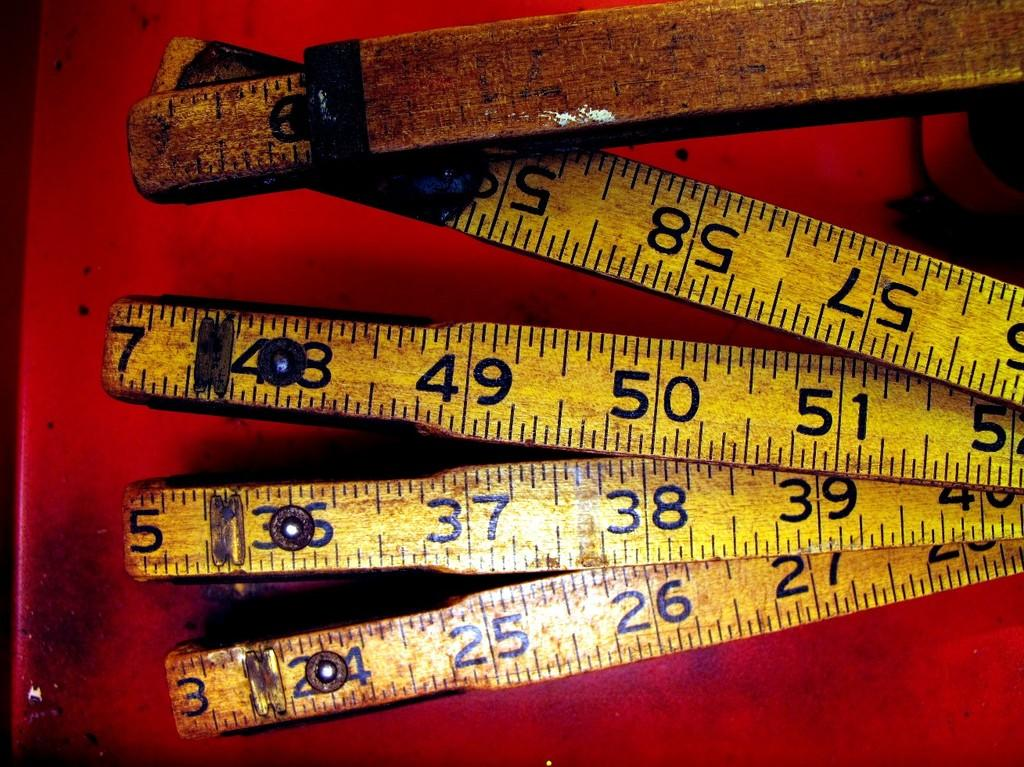Provide a one-sentence caption for the provided image. An old yellow ruler is folded up and jointed at numbers 3, 5 and 7. 